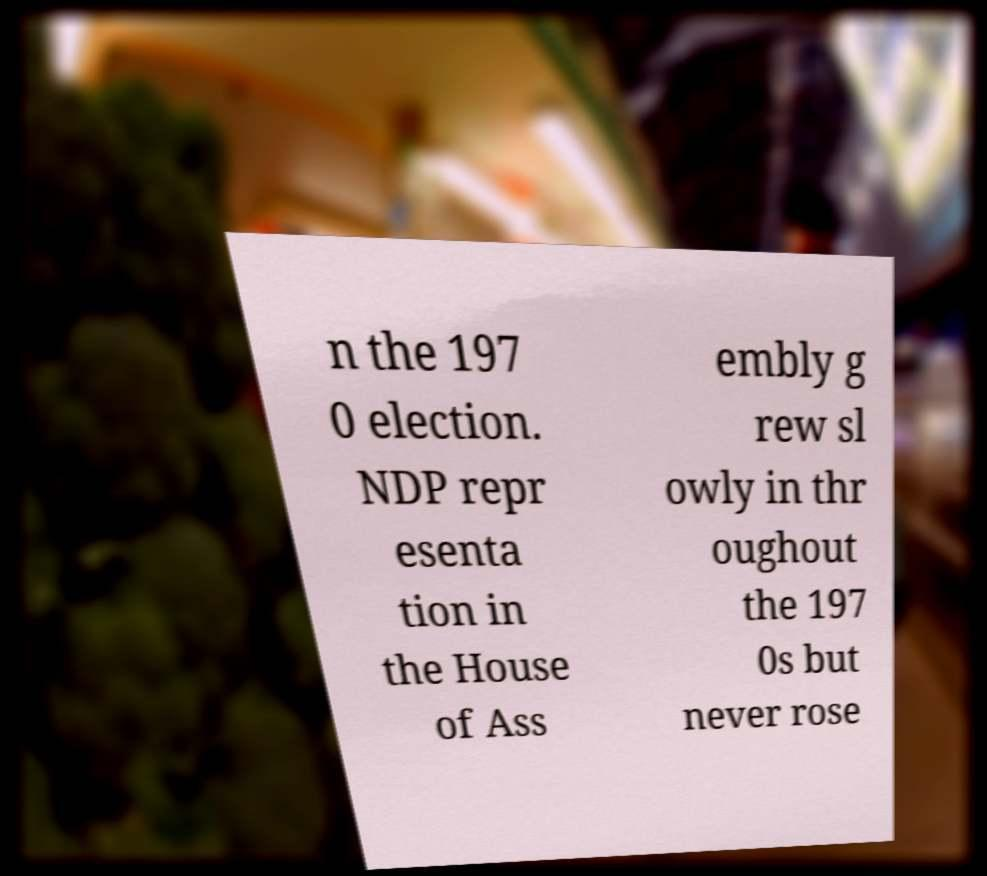Can you read and provide the text displayed in the image?This photo seems to have some interesting text. Can you extract and type it out for me? n the 197 0 election. NDP repr esenta tion in the House of Ass embly g rew sl owly in thr oughout the 197 0s but never rose 